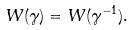Convert formula to latex. <formula><loc_0><loc_0><loc_500><loc_500>W ( \gamma ) = W ( \gamma ^ { - 1 } ) .</formula> 